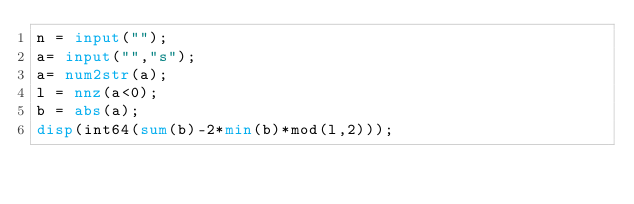Convert code to text. <code><loc_0><loc_0><loc_500><loc_500><_Octave_>n = input("");
a= input("","s");
a= num2str(a);
l = nnz(a<0);
b = abs(a);
disp(int64(sum(b)-2*min(b)*mod(l,2)));
</code> 